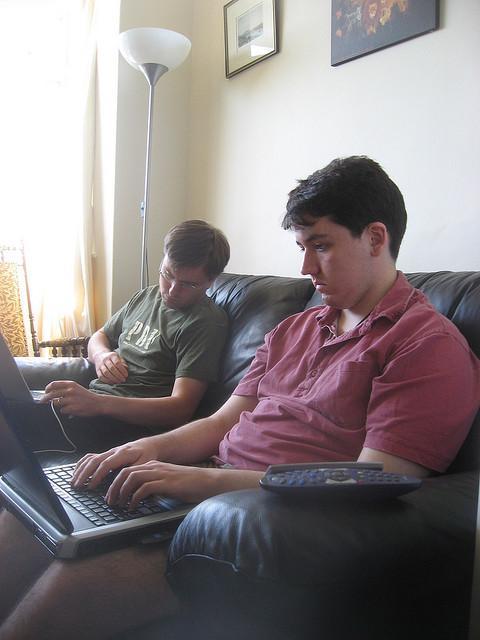How many people are there?
Give a very brief answer. 2. How many couches are visible?
Give a very brief answer. 2. 